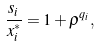Convert formula to latex. <formula><loc_0><loc_0><loc_500><loc_500>\frac { s _ { i } } { x _ { i } ^ { \ast } } = 1 + \rho ^ { q _ { i } } ,</formula> 